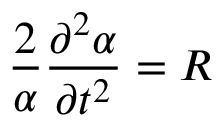Convert formula to latex. <formula><loc_0><loc_0><loc_500><loc_500>\frac { 2 } { \alpha } \frac { \partial ^ { 2 } \alpha } { \partial t ^ { 2 } } = R</formula> 